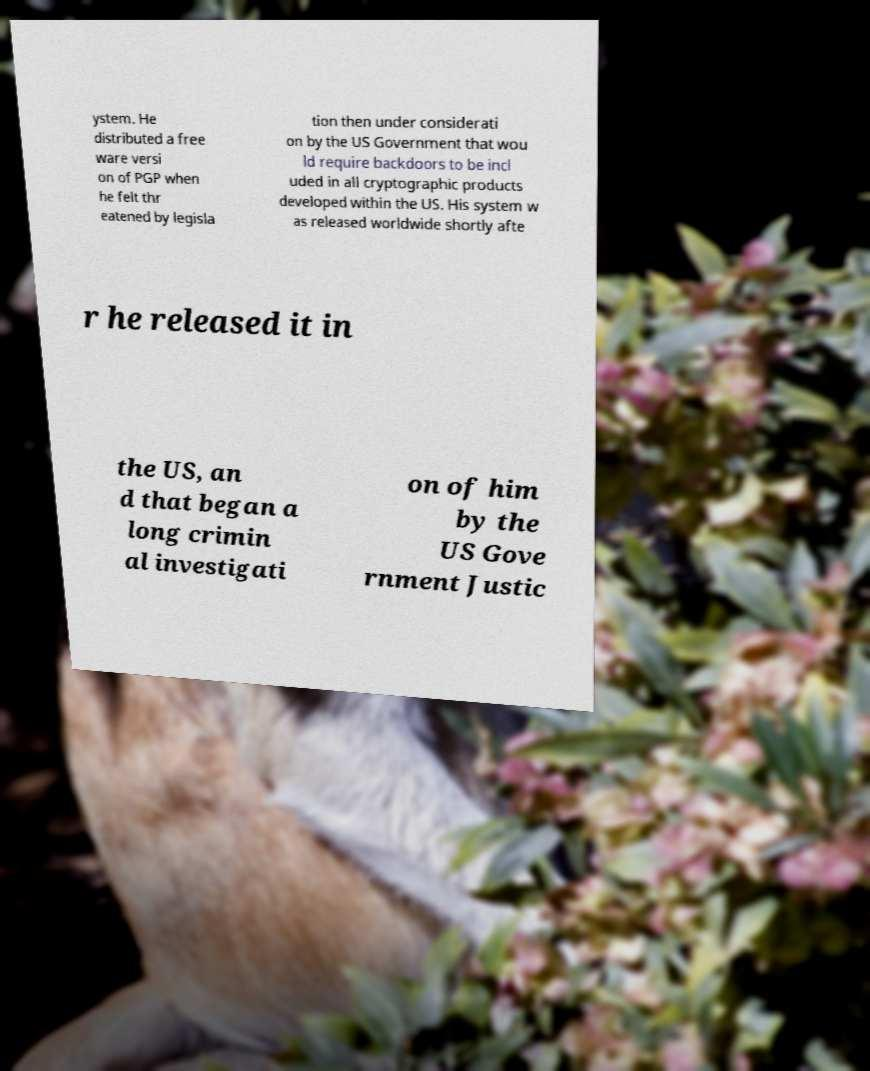Please read and relay the text visible in this image. What does it say? ystem. He distributed a free ware versi on of PGP when he felt thr eatened by legisla tion then under considerati on by the US Government that wou ld require backdoors to be incl uded in all cryptographic products developed within the US. His system w as released worldwide shortly afte r he released it in the US, an d that began a long crimin al investigati on of him by the US Gove rnment Justic 